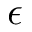<formula> <loc_0><loc_0><loc_500><loc_500>\epsilon</formula> 